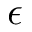<formula> <loc_0><loc_0><loc_500><loc_500>\epsilon</formula> 